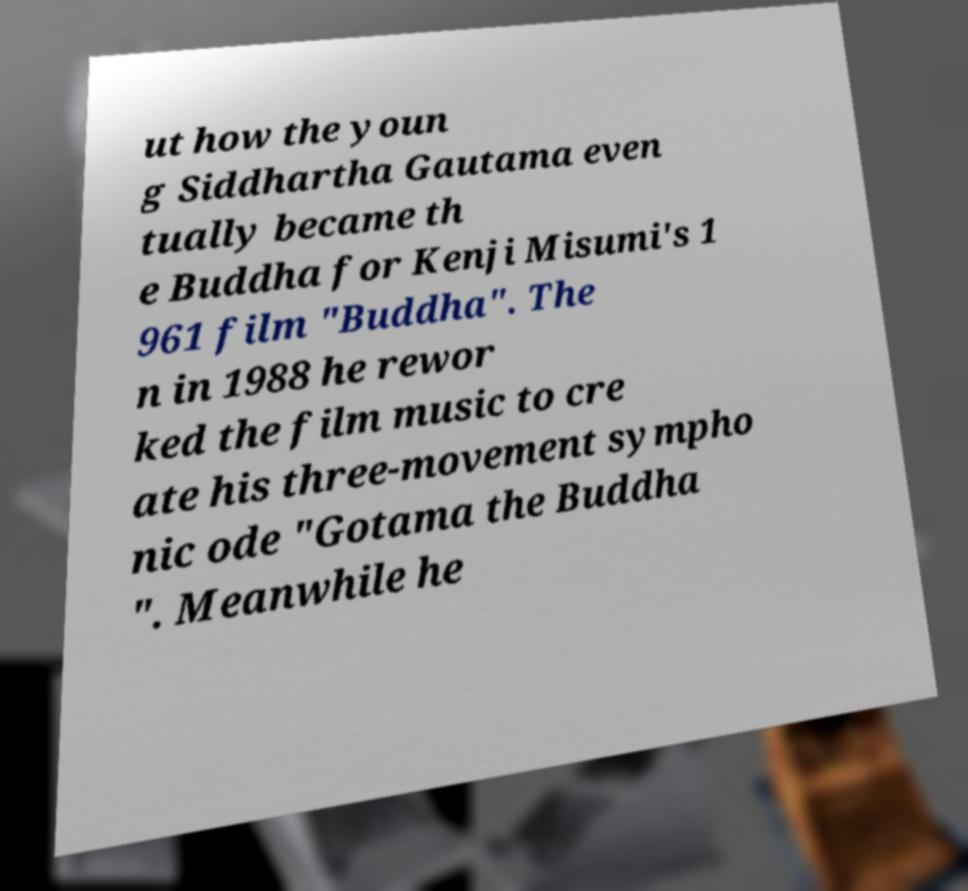Please read and relay the text visible in this image. What does it say? ut how the youn g Siddhartha Gautama even tually became th e Buddha for Kenji Misumi's 1 961 film "Buddha". The n in 1988 he rewor ked the film music to cre ate his three-movement sympho nic ode "Gotama the Buddha ". Meanwhile he 